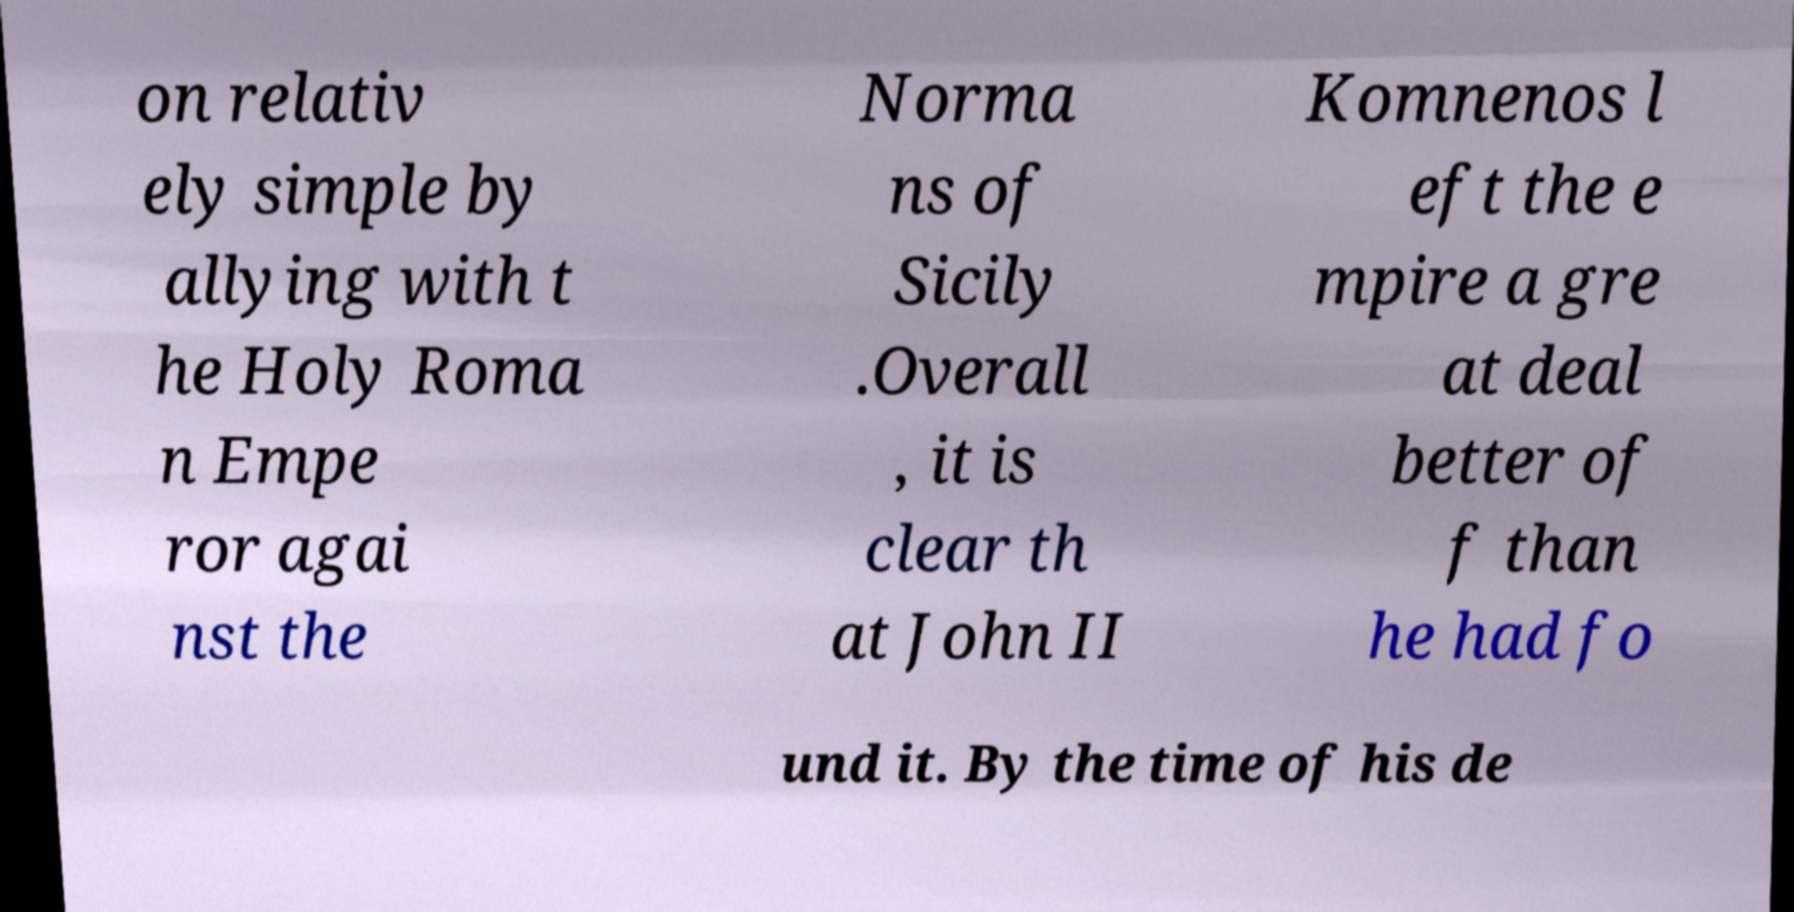Please identify and transcribe the text found in this image. on relativ ely simple by allying with t he Holy Roma n Empe ror agai nst the Norma ns of Sicily .Overall , it is clear th at John II Komnenos l eft the e mpire a gre at deal better of f than he had fo und it. By the time of his de 